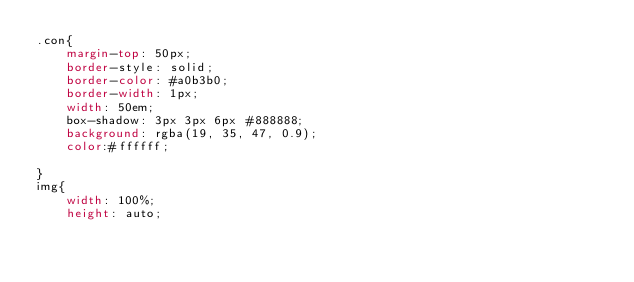Convert code to text. <code><loc_0><loc_0><loc_500><loc_500><_CSS_>.con{
    margin-top: 50px;
    border-style: solid;
    border-color: #a0b3b0;
    border-width: 1px;
    width: 50em;
    box-shadow: 3px 3px 6px #888888;
    background: rgba(19, 35, 47, 0.9);
    color:#ffffff;

}
img{
    width: 100%;
    height: auto;</code> 